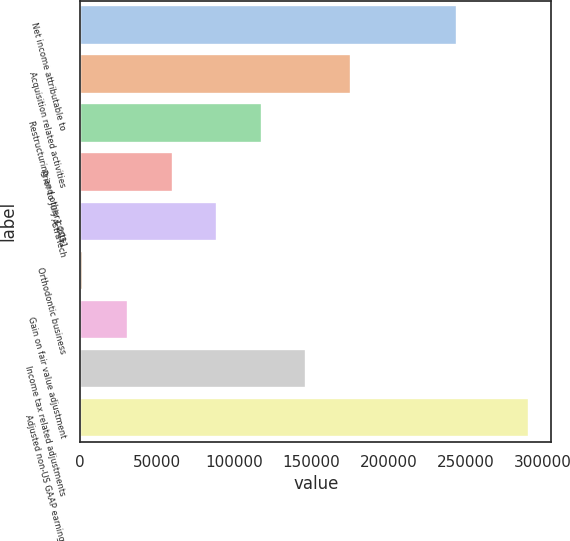Convert chart to OTSL. <chart><loc_0><loc_0><loc_500><loc_500><bar_chart><fcel>Net income attributable to<fcel>Acquisition related activities<fcel>Restructuring and other costs<fcel>Prior to July 1 2011<fcel>AstraTech<fcel>Orthodontic business<fcel>Gain on fair value adjustment<fcel>Income tax related adjustments<fcel>Adjusted non-US GAAP earnings<nl><fcel>244520<fcel>175374<fcel>117626<fcel>59876.8<fcel>88751.2<fcel>2128<fcel>31002.4<fcel>146500<fcel>290872<nl></chart> 